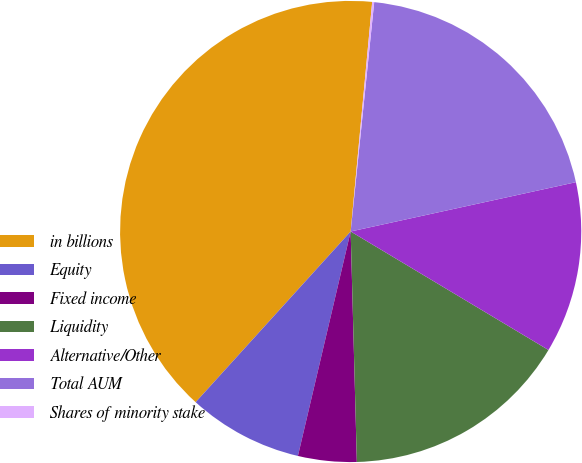Convert chart to OTSL. <chart><loc_0><loc_0><loc_500><loc_500><pie_chart><fcel>in billions<fcel>Equity<fcel>Fixed income<fcel>Liquidity<fcel>Alternative/Other<fcel>Total AUM<fcel>Shares of minority stake<nl><fcel>39.75%<fcel>8.06%<fcel>4.1%<fcel>15.98%<fcel>12.02%<fcel>19.94%<fcel>0.14%<nl></chart> 